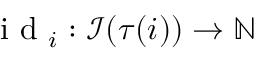Convert formula to latex. <formula><loc_0><loc_0><loc_500><loc_500>i d _ { i } \colon \mathcal { I } ( \tau ( i ) ) \rightarrow \mathbb { N }</formula> 